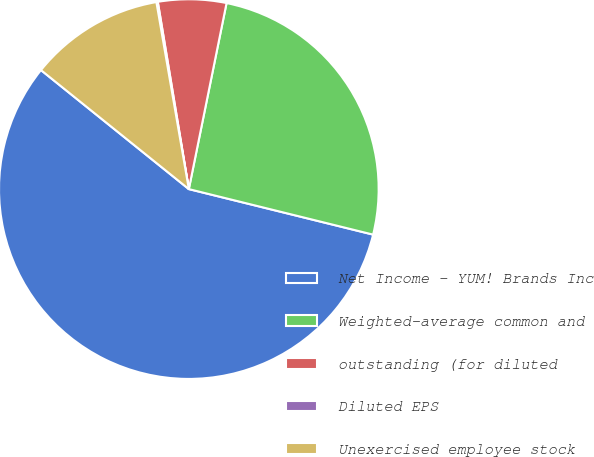Convert chart to OTSL. <chart><loc_0><loc_0><loc_500><loc_500><pie_chart><fcel>Net Income - YUM! Brands Inc<fcel>Weighted-average common and<fcel>outstanding (for diluted<fcel>Diluted EPS<fcel>Unexercised employee stock<nl><fcel>56.93%<fcel>25.67%<fcel>5.8%<fcel>0.12%<fcel>11.48%<nl></chart> 